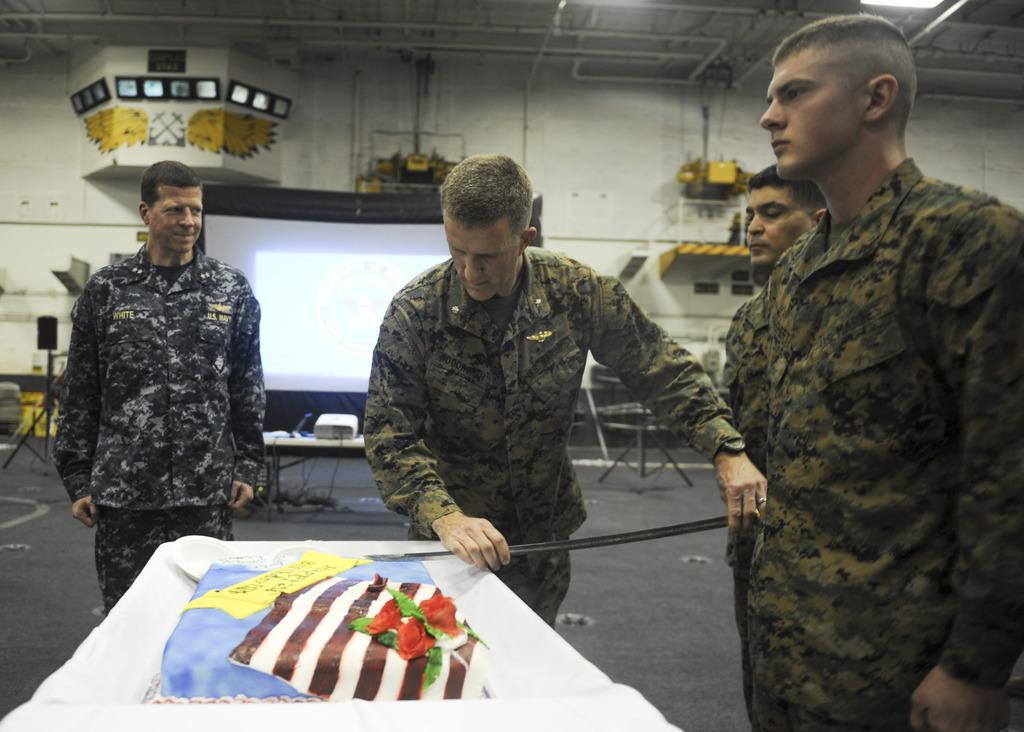Can you describe this image briefly? In the foreground of this image, there is a cake on the table and also there are four men standing near it where a man is holding an object. In the background, there is a screen, projector on the table, few objects on the tripod stands, few screens, walls, pipes and a light to the ceiling. 